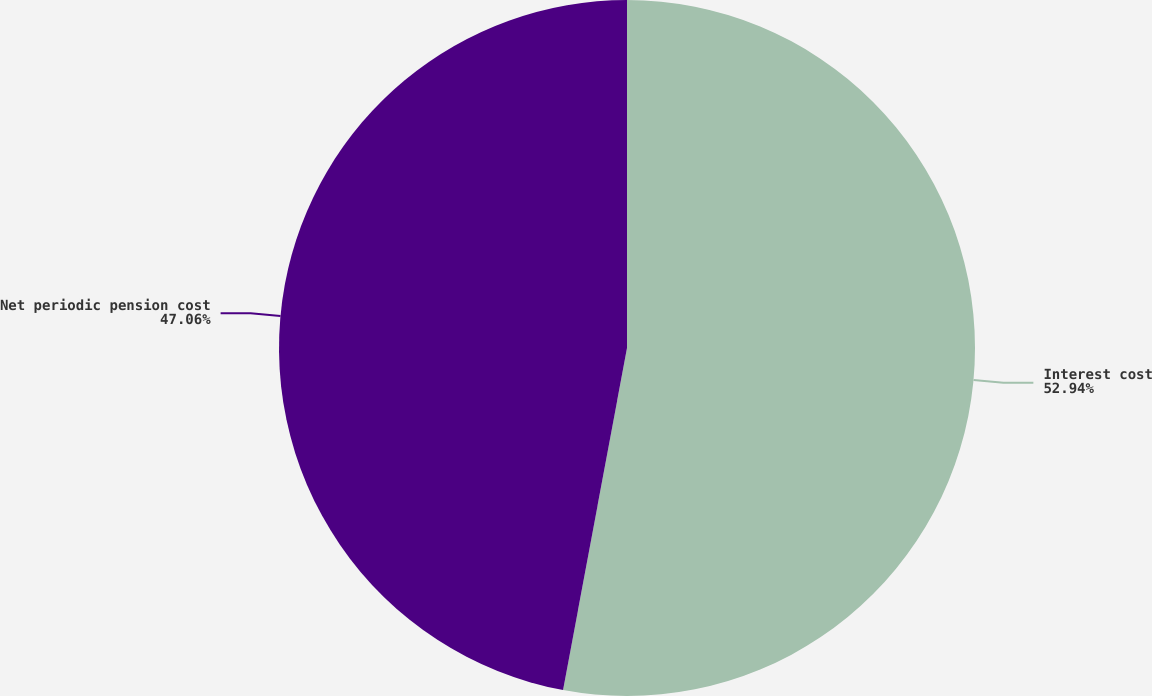<chart> <loc_0><loc_0><loc_500><loc_500><pie_chart><fcel>Interest cost<fcel>Net periodic pension cost<nl><fcel>52.94%<fcel>47.06%<nl></chart> 